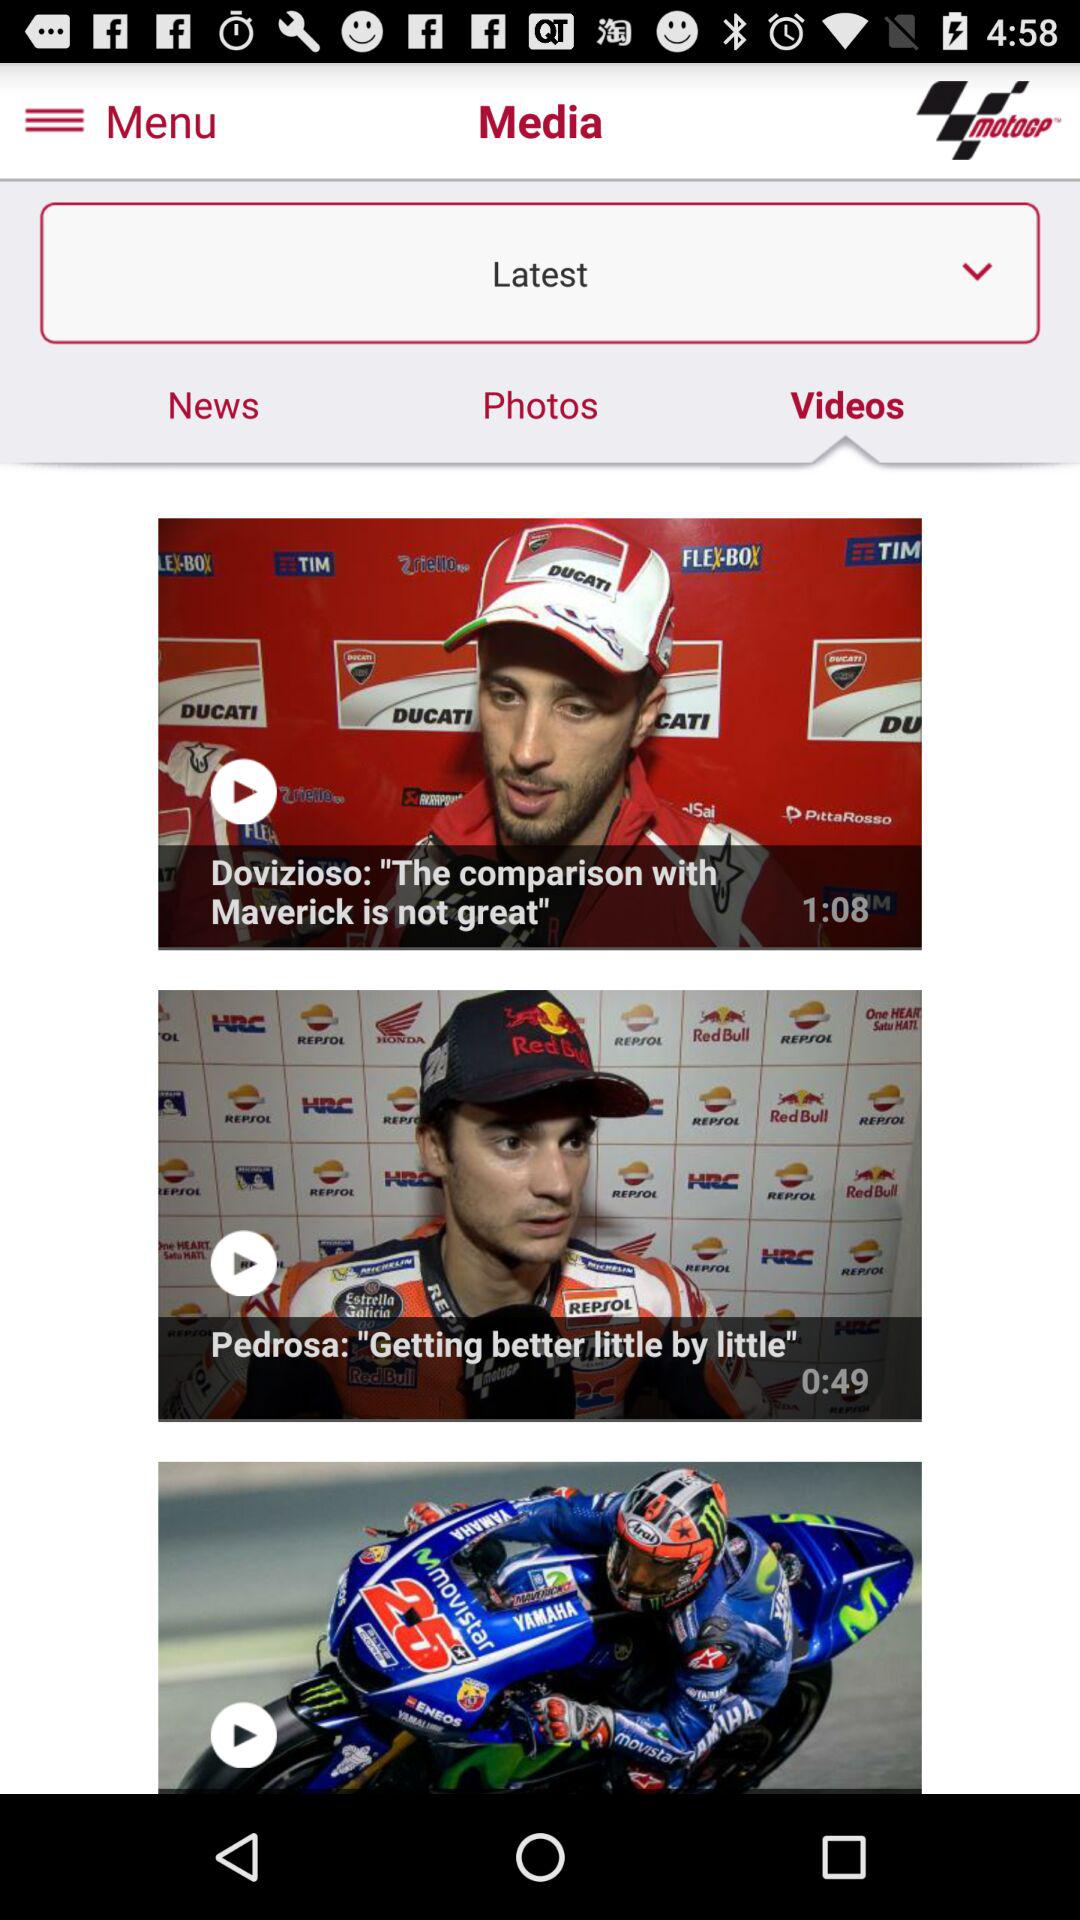How many videos are on the latest page?
Answer the question using a single word or phrase. 3 